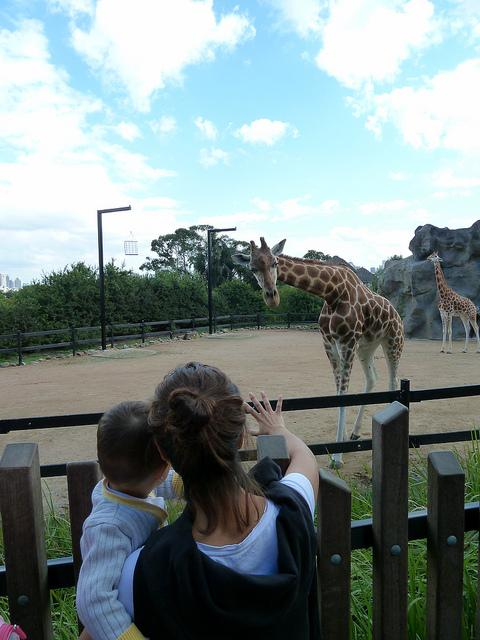What is the hanging basket for?

Choices:
A) storing food
B) decoration
C) game
D) lantern storing food 